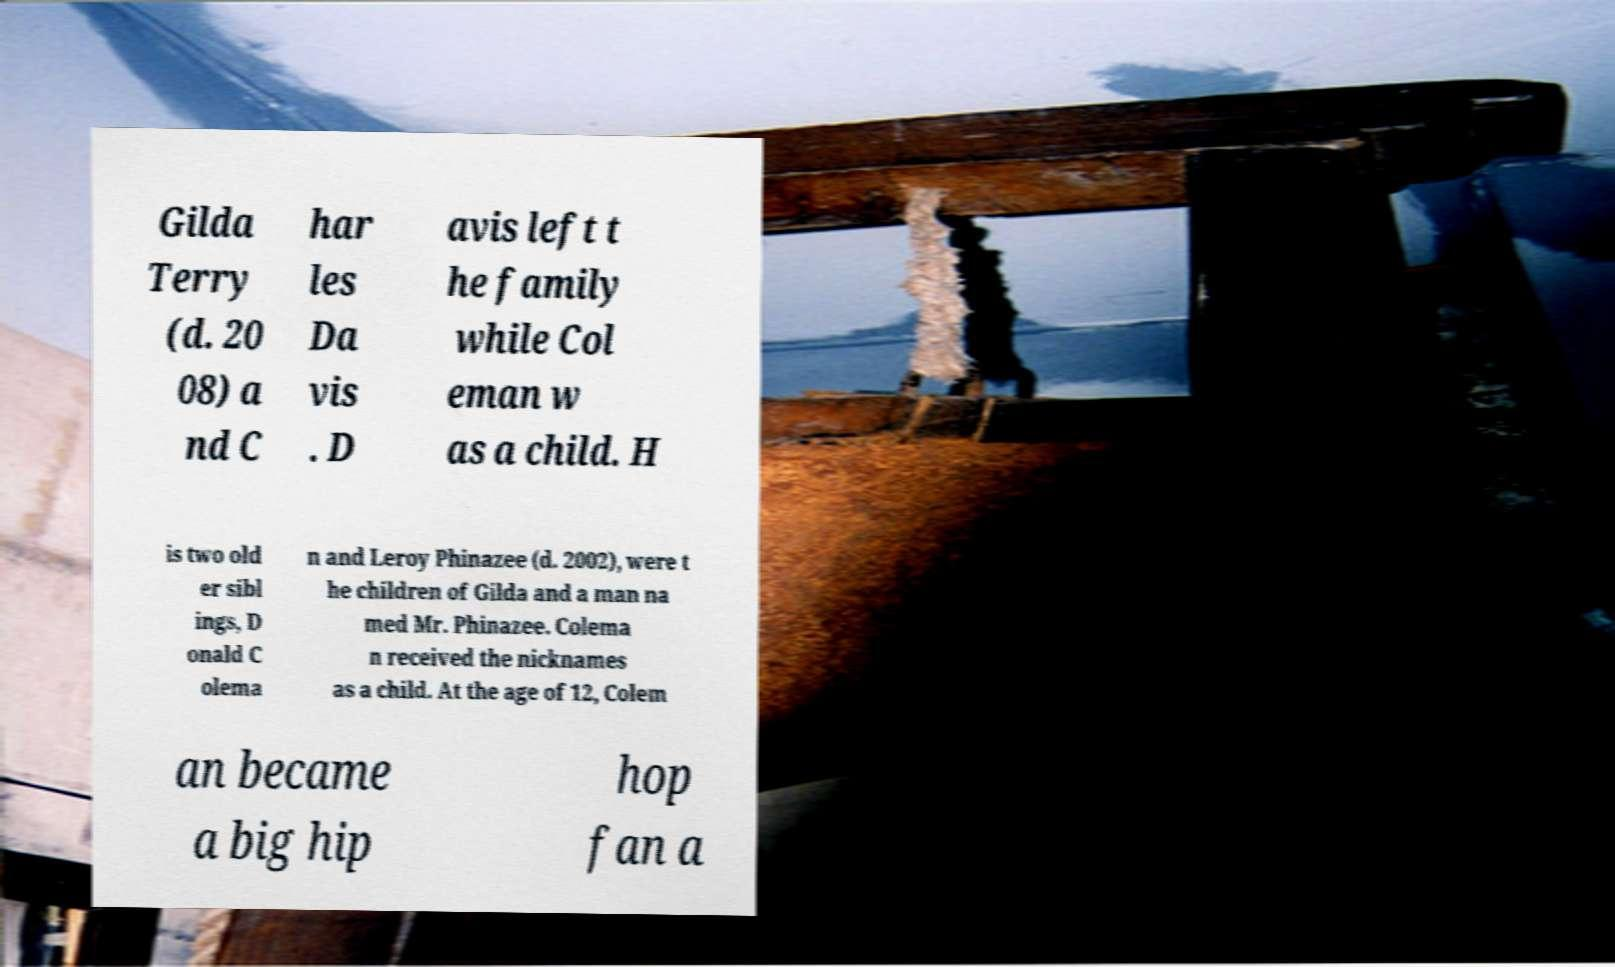For documentation purposes, I need the text within this image transcribed. Could you provide that? Gilda Terry (d. 20 08) a nd C har les Da vis . D avis left t he family while Col eman w as a child. H is two old er sibl ings, D onald C olema n and Leroy Phinazee (d. 2002), were t he children of Gilda and a man na med Mr. Phinazee. Colema n received the nicknames as a child. At the age of 12, Colem an became a big hip hop fan a 